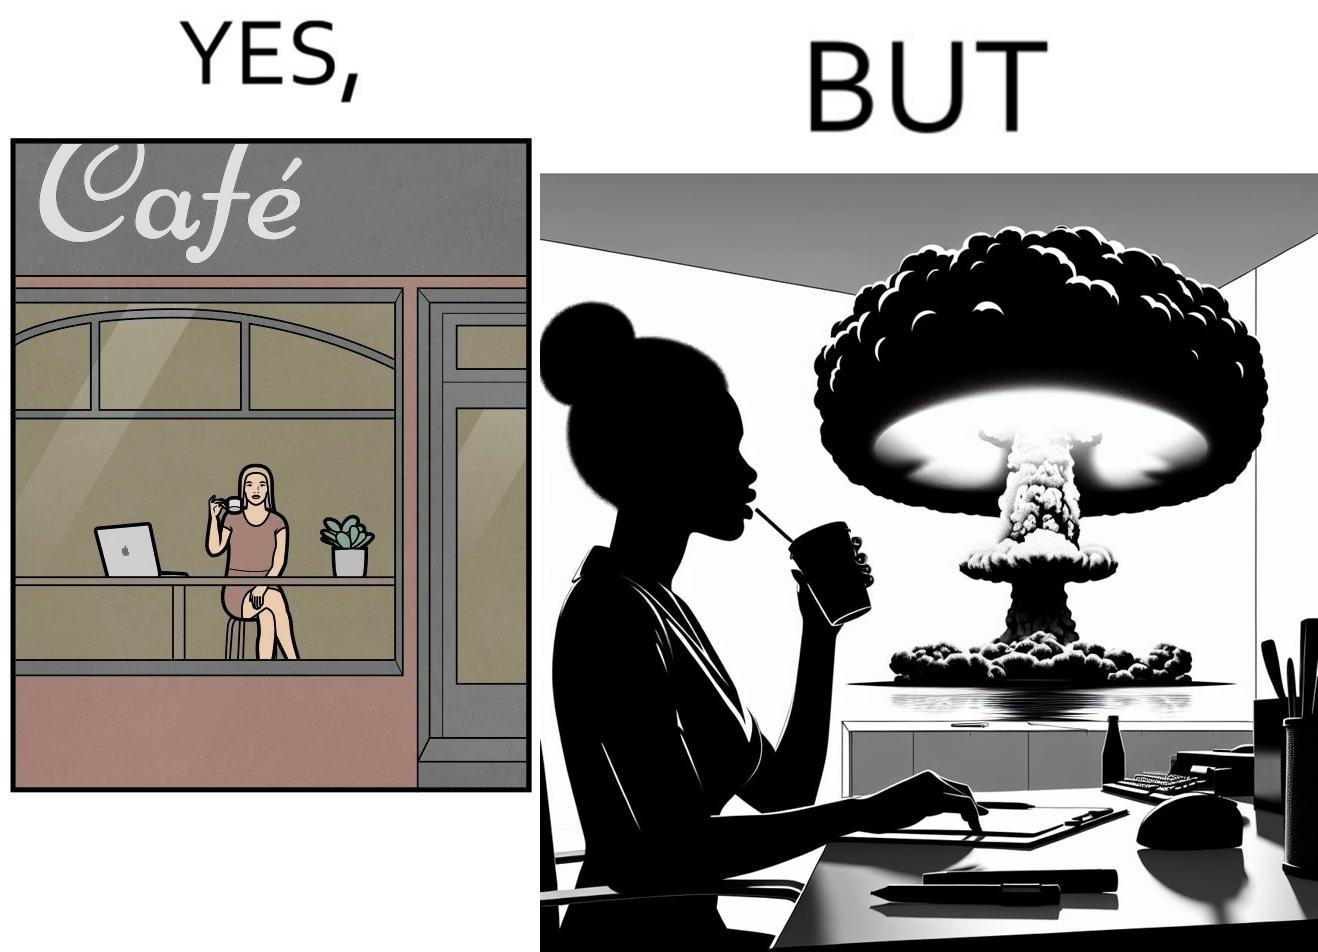Is there satirical content in this image? Yes, this image is satirical. 